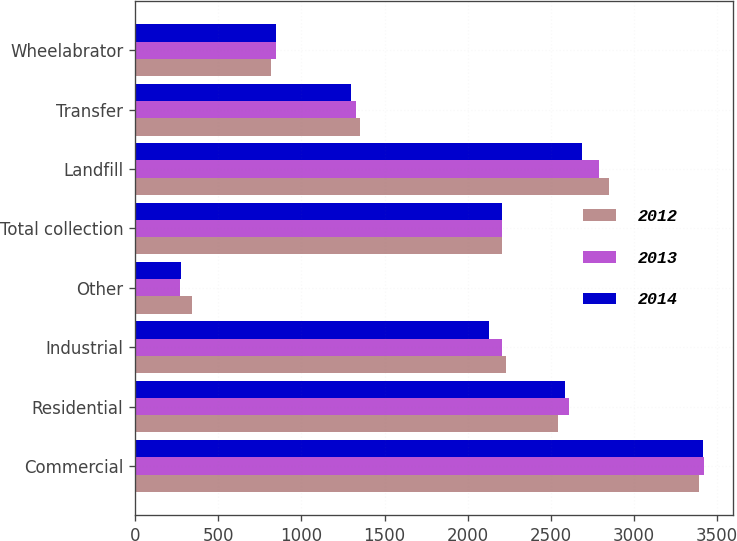Convert chart. <chart><loc_0><loc_0><loc_500><loc_500><stacked_bar_chart><ecel><fcel>Commercial<fcel>Residential<fcel>Industrial<fcel>Other<fcel>Total collection<fcel>Landfill<fcel>Transfer<fcel>Wheelabrator<nl><fcel>2012<fcel>3393<fcel>2543<fcel>2231<fcel>340<fcel>2209<fcel>2849<fcel>1353<fcel>817<nl><fcel>2013<fcel>3423<fcel>2608<fcel>2209<fcel>273<fcel>2209<fcel>2790<fcel>1329<fcel>845<nl><fcel>2014<fcel>3417<fcel>2584<fcel>2129<fcel>275<fcel>2209<fcel>2685<fcel>1296<fcel>846<nl></chart> 